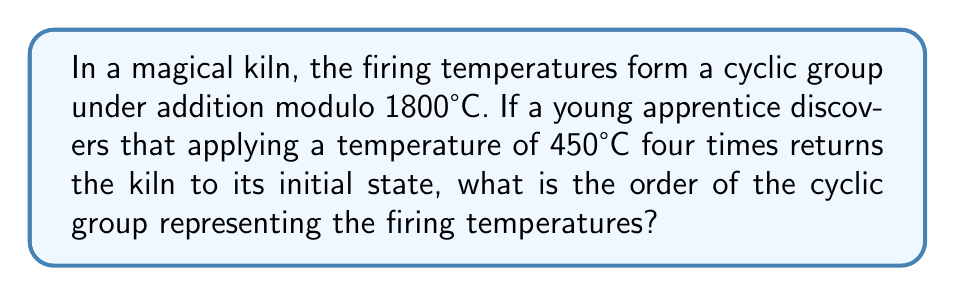What is the answer to this math problem? Let's approach this step-by-step:

1) In a cyclic group, the order of the group is equal to the smallest positive integer $n$ such that $a^n = e$, where $a$ is a generator of the group and $e$ is the identity element.

2) In this case, we're working with addition modulo 1800°C. So, we need to find the smallest positive integer $n$ such that $n \cdot 450 \equiv 0 \pmod{1800}$.

3) We're told that applying 450°C four times returns the kiln to its initial state. This means:

   $4 \cdot 450 \equiv 0 \pmod{1800}$

4) Let's verify this:
   $4 \cdot 450 = 1800 \equiv 0 \pmod{1800}$

5) This confirms that 4 is indeed the smallest positive integer that satisfies the condition.

6) In group theory, this means that 450°C generates a subgroup of order 4 within the larger cyclic group.

7) The order of the entire group must be divisible by the order of any subgroup. Therefore, the order of the full cyclic group must be divisible by 4.

8) The largest possible order for this group is 1800 (since we're working modulo 1800°C).

9) Therefore, the order of the full cyclic group is 1800.
Answer: The order of the cyclic group representing the firing temperatures is 1800. 